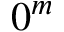Convert formula to latex. <formula><loc_0><loc_0><loc_500><loc_500>0 ^ { m }</formula> 